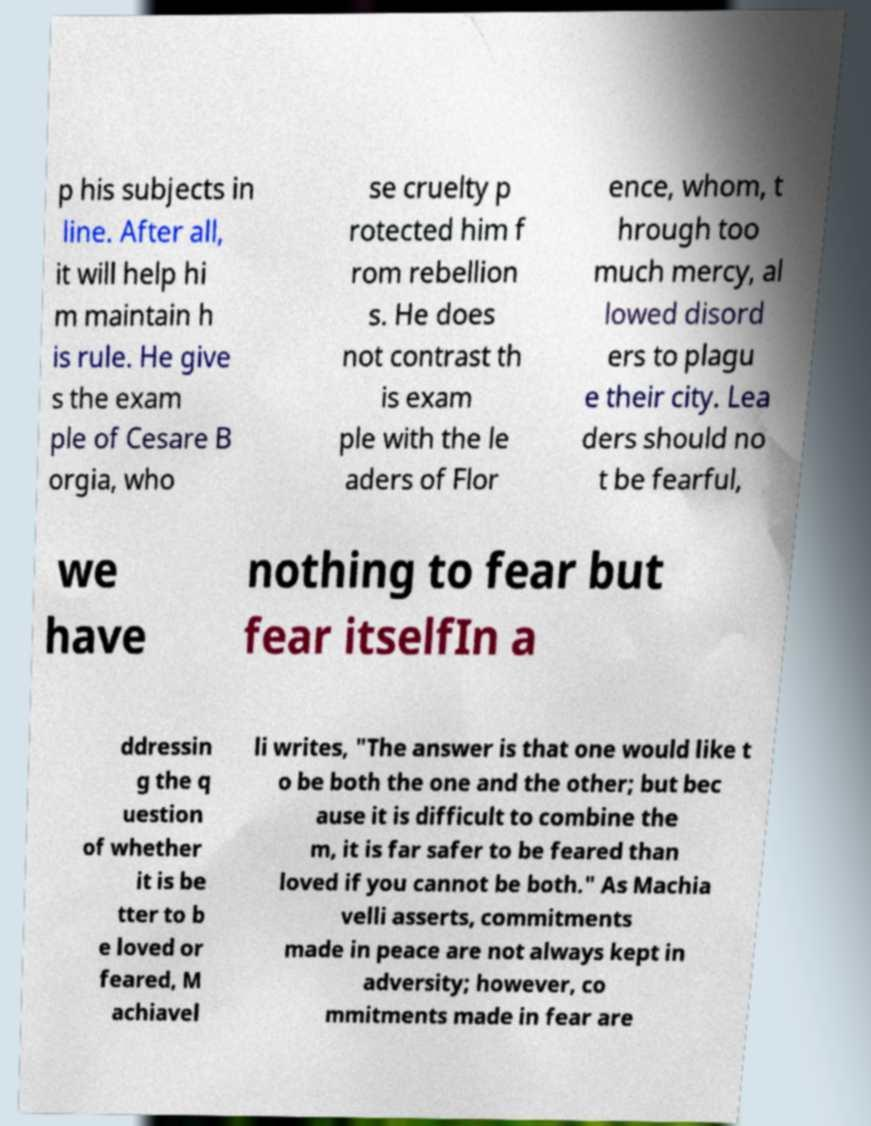There's text embedded in this image that I need extracted. Can you transcribe it verbatim? p his subjects in line. After all, it will help hi m maintain h is rule. He give s the exam ple of Cesare B orgia, who se cruelty p rotected him f rom rebellion s. He does not contrast th is exam ple with the le aders of Flor ence, whom, t hrough too much mercy, al lowed disord ers to plagu e their city. Lea ders should no t be fearful, we have nothing to fear but fear itselfIn a ddressin g the q uestion of whether it is be tter to b e loved or feared, M achiavel li writes, "The answer is that one would like t o be both the one and the other; but bec ause it is difficult to combine the m, it is far safer to be feared than loved if you cannot be both." As Machia velli asserts, commitments made in peace are not always kept in adversity; however, co mmitments made in fear are 